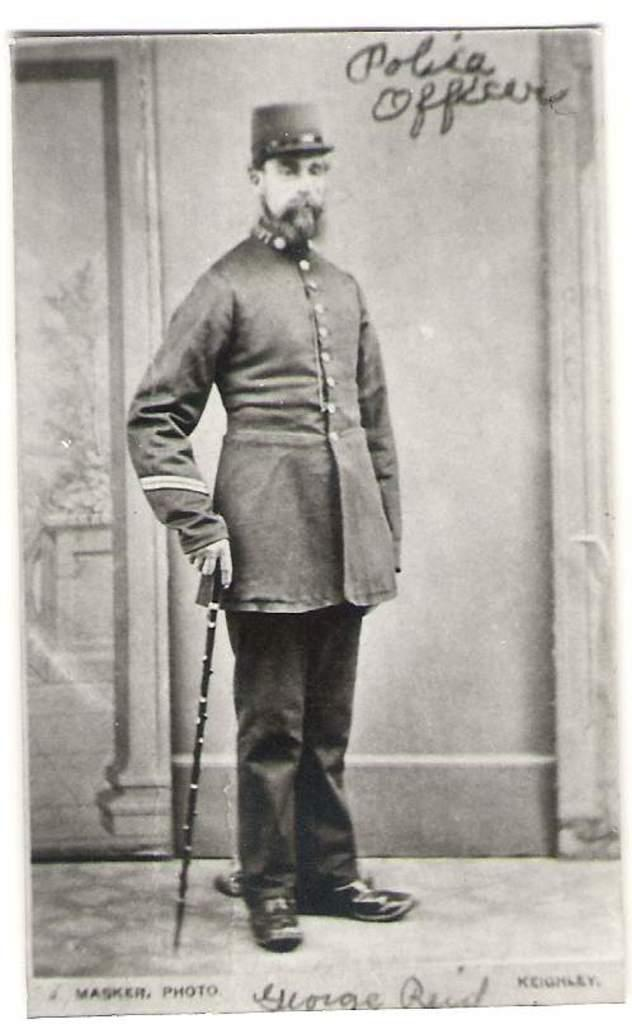<image>
Describe the image concisely. A photographed of a uniformed man is labelled "police officer." 